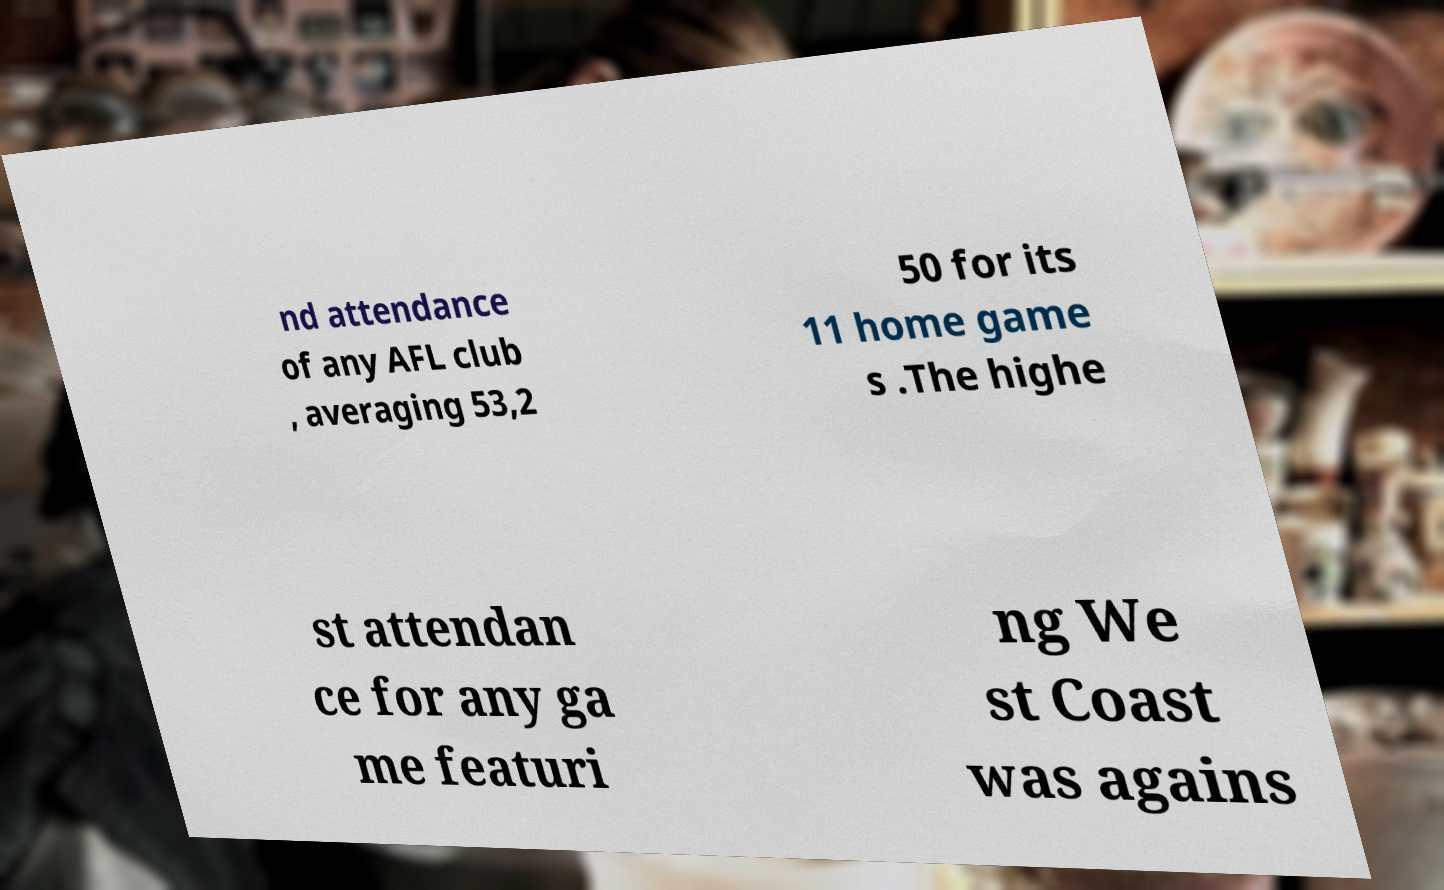I need the written content from this picture converted into text. Can you do that? nd attendance of any AFL club , averaging 53,2 50 for its 11 home game s .The highe st attendan ce for any ga me featuri ng We st Coast was agains 